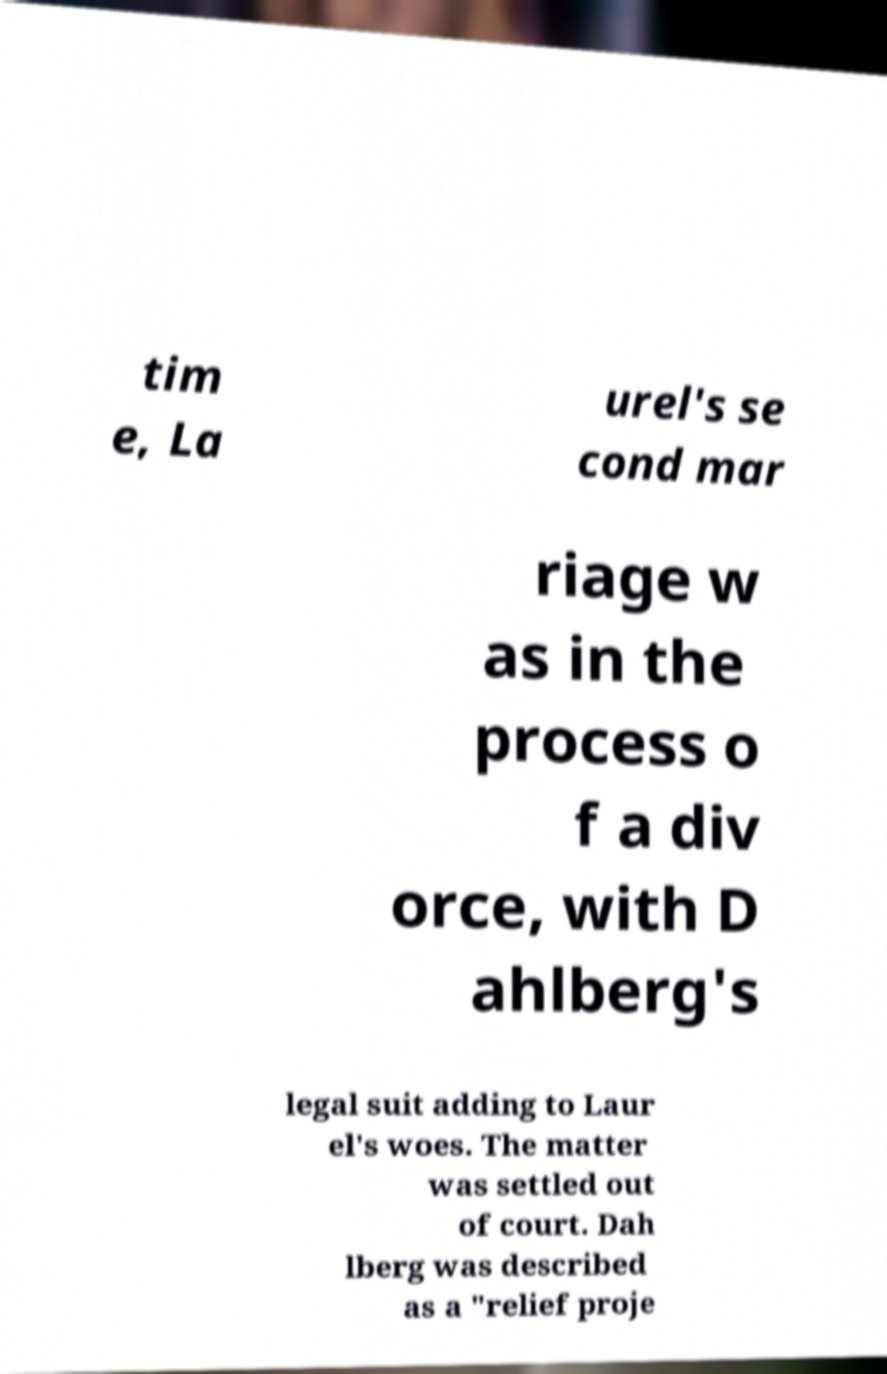Can you read and provide the text displayed in the image?This photo seems to have some interesting text. Can you extract and type it out for me? tim e, La urel's se cond mar riage w as in the process o f a div orce, with D ahlberg's legal suit adding to Laur el's woes. The matter was settled out of court. Dah lberg was described as a "relief proje 